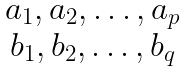<formula> <loc_0><loc_0><loc_500><loc_500>\begin{matrix} \ a _ { 1 } , a _ { 2 } , \dots , a _ { p } \\ \ b _ { 1 } , b _ { 2 } , \dots , b _ { q } \end{matrix}</formula> 